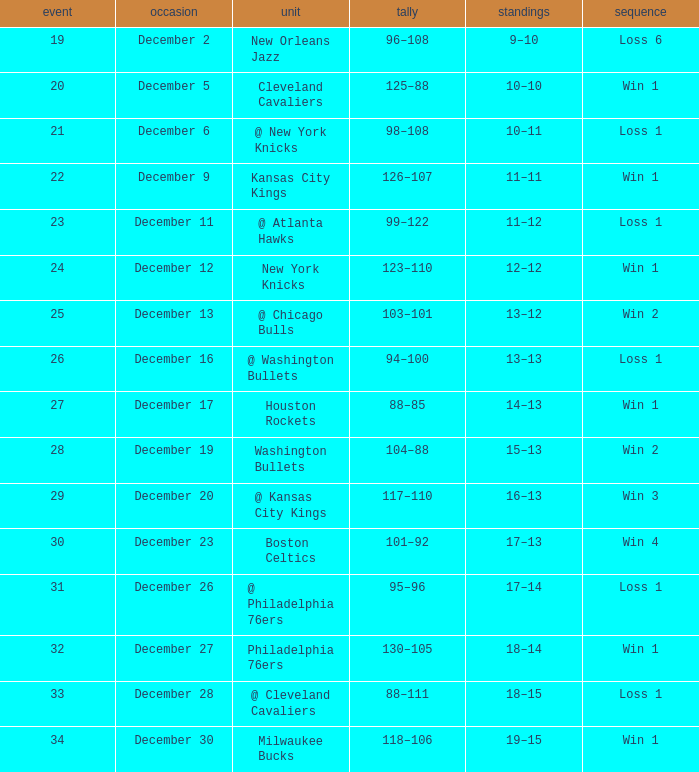What is the Streak on December 30? Win 1. 